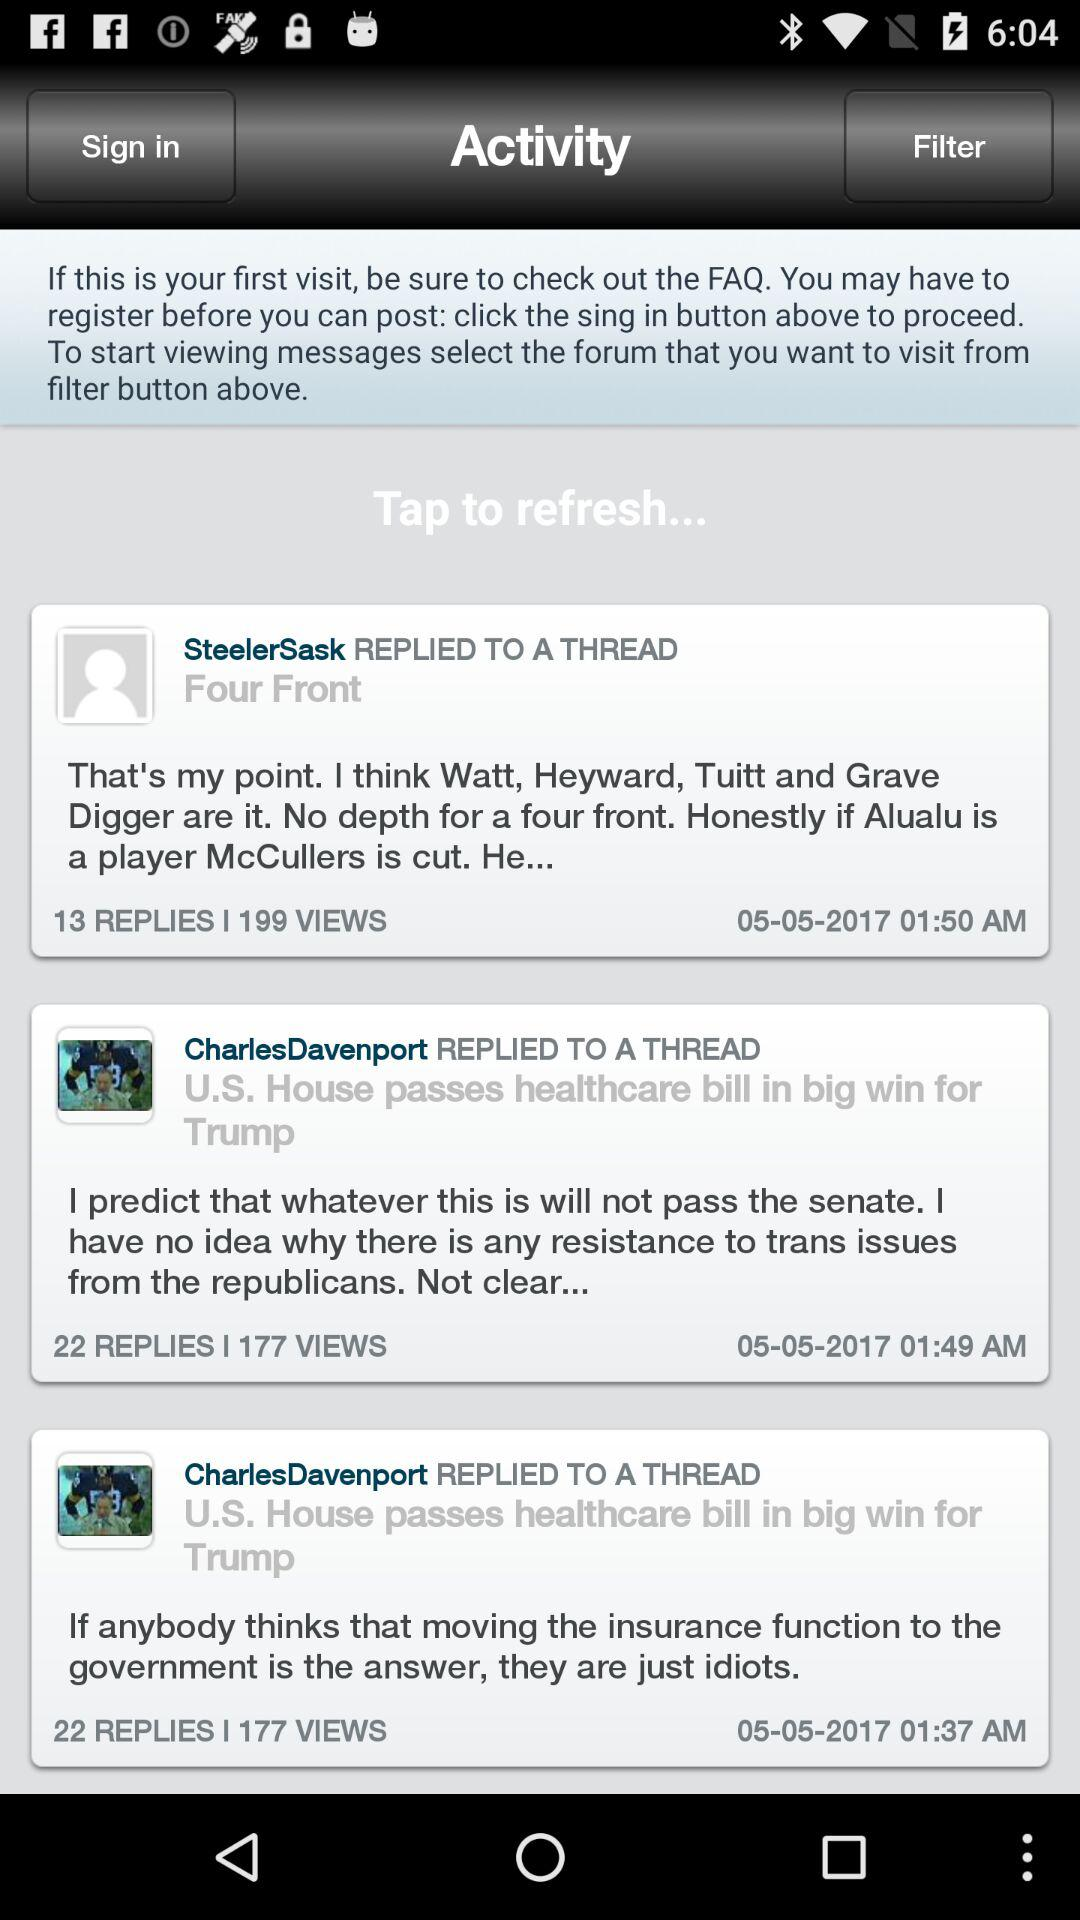Who posted the comment at 1:37 am? The comment was posted by CharlesDavenport. 